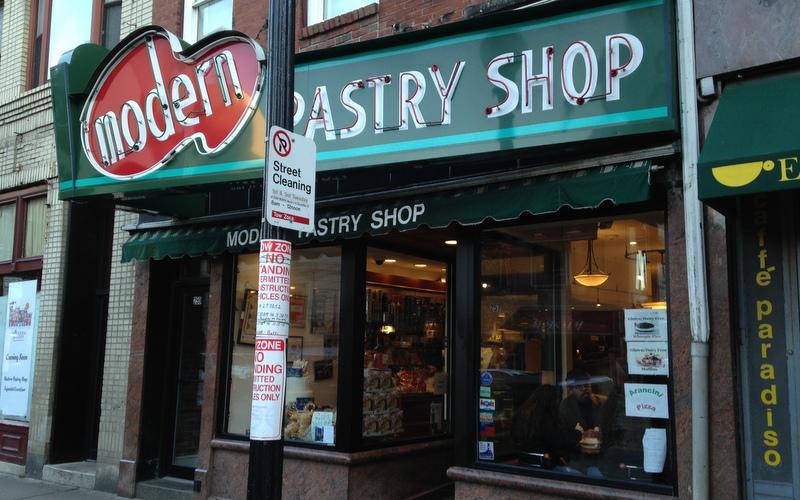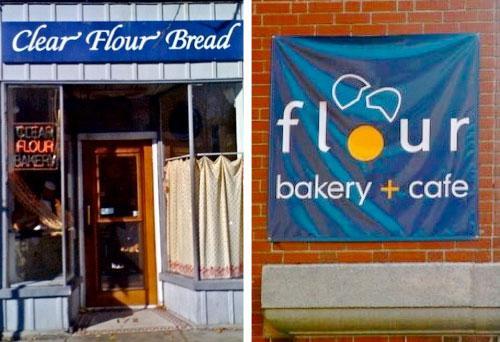The first image is the image on the left, the second image is the image on the right. Given the left and right images, does the statement "There is a metal rack with various breads and pastries on it, there are tags in the image on the shelves labeling the products" hold true? Answer yes or no. No. The first image is the image on the left, the second image is the image on the right. Considering the images on both sides, is "In at least one image there is a single brown front door under blue signage." valid? Answer yes or no. Yes. 